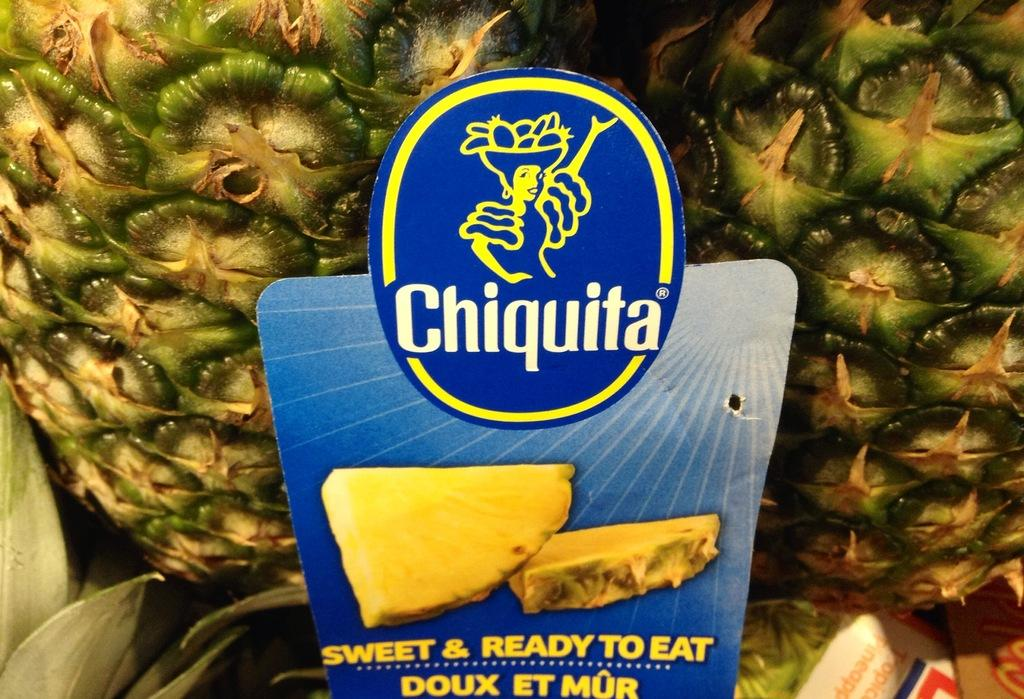What type of fruit is present in the image? There are pineapples in the image. Is there any additional information provided about the pineapples? Yes, there is a tag in the image. What can be seen at the bottom of the image? Leaves are visible at the bottom of the image, and there are some objects present as well. Are there any cobwebs visible in the image? No, there are no cobwebs present in the image. 